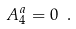<formula> <loc_0><loc_0><loc_500><loc_500>A ^ { a } _ { 4 } = 0 \ .</formula> 